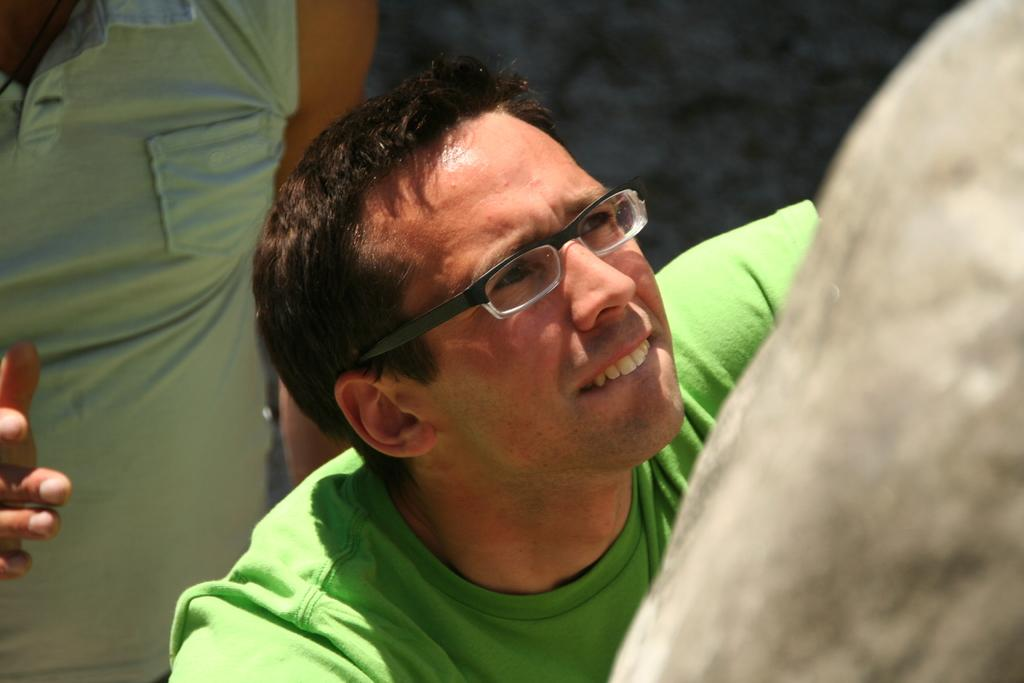What is present in the image? There are people in the image. Can you describe the visibility of the people's faces in the image? Only one person's face is visible in the image. What type of zipper can be seen on the woman's dress in the image? There is no woman or dress present in the image, so there is no zipper to describe. 